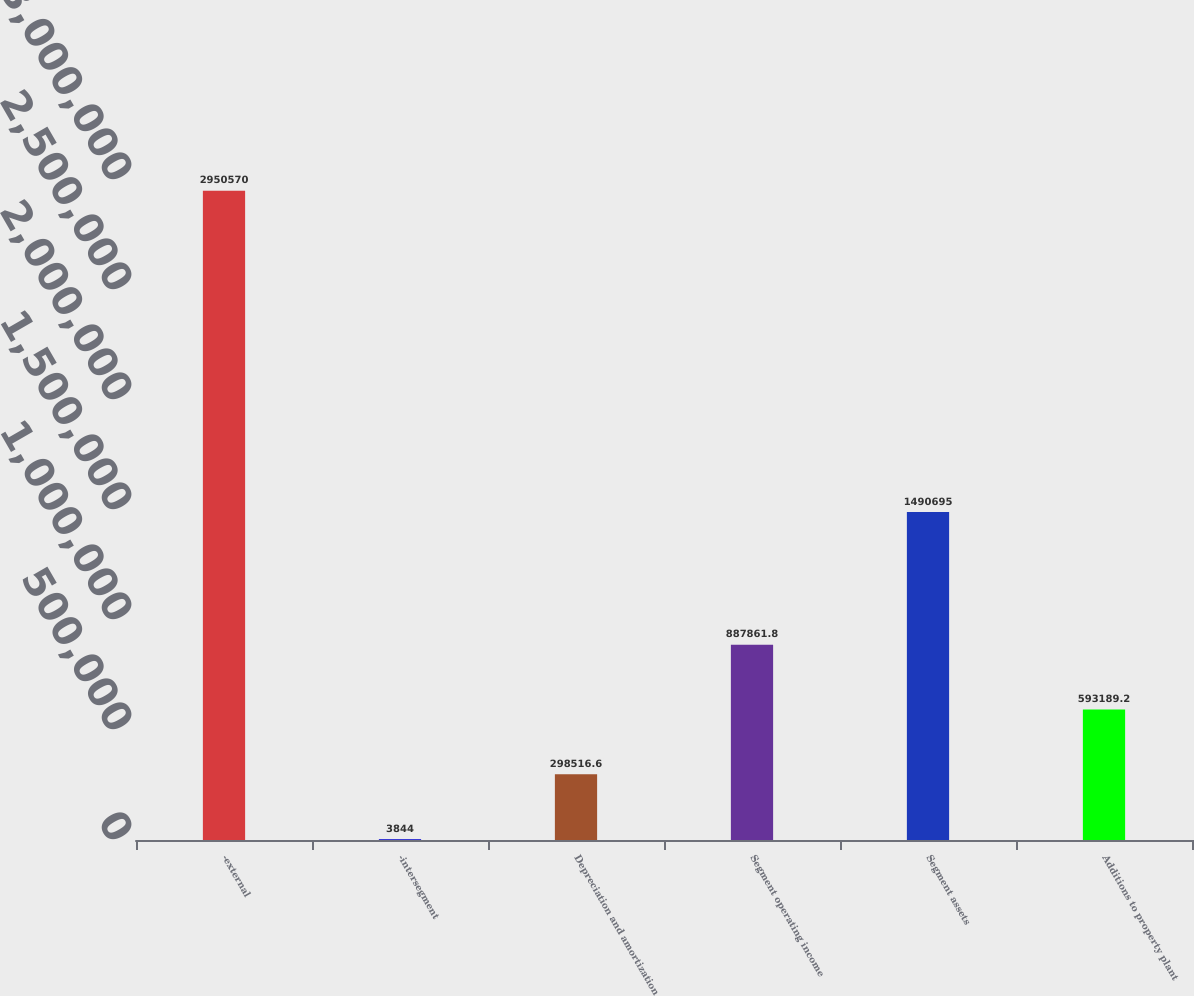<chart> <loc_0><loc_0><loc_500><loc_500><bar_chart><fcel>-external<fcel>-intersegment<fcel>Depreciation and amortization<fcel>Segment operating income<fcel>Segment assets<fcel>Additions to property plant<nl><fcel>2.95057e+06<fcel>3844<fcel>298517<fcel>887862<fcel>1.4907e+06<fcel>593189<nl></chart> 